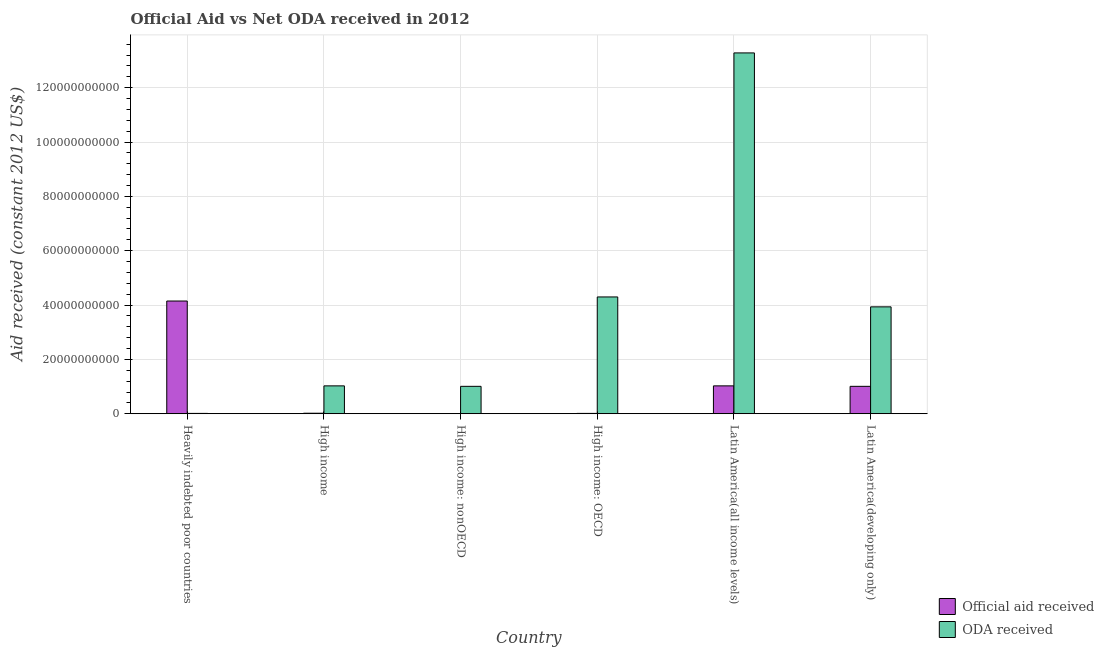How many groups of bars are there?
Offer a very short reply. 6. Are the number of bars per tick equal to the number of legend labels?
Your response must be concise. Yes. How many bars are there on the 3rd tick from the left?
Your answer should be very brief. 2. What is the label of the 4th group of bars from the left?
Your answer should be very brief. High income: OECD. What is the oda received in Heavily indebted poor countries?
Your answer should be very brief. 1.25e+08. Across all countries, what is the maximum official aid received?
Keep it short and to the point. 4.15e+1. Across all countries, what is the minimum official aid received?
Your answer should be compact. 5.78e+07. In which country was the oda received maximum?
Your response must be concise. Latin America(all income levels). In which country was the oda received minimum?
Provide a succinct answer. Heavily indebted poor countries. What is the total oda received in the graph?
Your answer should be very brief. 2.36e+11. What is the difference between the official aid received in High income and that in Latin America(all income levels)?
Provide a succinct answer. -1.01e+1. What is the difference between the oda received in Latin America(developing only) and the official aid received in High income: nonOECD?
Offer a very short reply. 3.93e+1. What is the average official aid received per country?
Provide a succinct answer. 1.04e+1. What is the difference between the official aid received and oda received in Latin America(all income levels)?
Ensure brevity in your answer.  -1.23e+11. In how many countries, is the official aid received greater than 40000000000 US$?
Provide a short and direct response. 1. What is the ratio of the oda received in High income to that in High income: OECD?
Make the answer very short. 0.24. Is the difference between the official aid received in High income and Latin America(all income levels) greater than the difference between the oda received in High income and Latin America(all income levels)?
Provide a short and direct response. Yes. What is the difference between the highest and the second highest oda received?
Ensure brevity in your answer.  8.98e+1. What is the difference between the highest and the lowest official aid received?
Give a very brief answer. 4.14e+1. What does the 1st bar from the left in Latin America(all income levels) represents?
Provide a short and direct response. Official aid received. What does the 2nd bar from the right in Heavily indebted poor countries represents?
Give a very brief answer. Official aid received. Are all the bars in the graph horizontal?
Provide a succinct answer. No. How many countries are there in the graph?
Your answer should be compact. 6. Are the values on the major ticks of Y-axis written in scientific E-notation?
Your answer should be compact. No. Where does the legend appear in the graph?
Offer a very short reply. Bottom right. How are the legend labels stacked?
Your answer should be compact. Vertical. What is the title of the graph?
Keep it short and to the point. Official Aid vs Net ODA received in 2012 . Does "Goods and services" appear as one of the legend labels in the graph?
Make the answer very short. No. What is the label or title of the Y-axis?
Keep it short and to the point. Aid received (constant 2012 US$). What is the Aid received (constant 2012 US$) of Official aid received in Heavily indebted poor countries?
Make the answer very short. 4.15e+1. What is the Aid received (constant 2012 US$) in ODA received in Heavily indebted poor countries?
Provide a short and direct response. 1.25e+08. What is the Aid received (constant 2012 US$) in Official aid received in High income?
Your response must be concise. 1.88e+08. What is the Aid received (constant 2012 US$) in ODA received in High income?
Offer a terse response. 1.03e+1. What is the Aid received (constant 2012 US$) of Official aid received in High income: nonOECD?
Your answer should be compact. 5.78e+07. What is the Aid received (constant 2012 US$) in ODA received in High income: nonOECD?
Your answer should be compact. 1.01e+1. What is the Aid received (constant 2012 US$) of Official aid received in High income: OECD?
Offer a terse response. 1.25e+08. What is the Aid received (constant 2012 US$) in ODA received in High income: OECD?
Keep it short and to the point. 4.30e+1. What is the Aid received (constant 2012 US$) of Official aid received in Latin America(all income levels)?
Offer a very short reply. 1.03e+1. What is the Aid received (constant 2012 US$) of ODA received in Latin America(all income levels)?
Offer a terse response. 1.33e+11. What is the Aid received (constant 2012 US$) in Official aid received in Latin America(developing only)?
Offer a terse response. 1.01e+1. What is the Aid received (constant 2012 US$) in ODA received in Latin America(developing only)?
Keep it short and to the point. 3.93e+1. Across all countries, what is the maximum Aid received (constant 2012 US$) in Official aid received?
Give a very brief answer. 4.15e+1. Across all countries, what is the maximum Aid received (constant 2012 US$) in ODA received?
Offer a very short reply. 1.33e+11. Across all countries, what is the minimum Aid received (constant 2012 US$) of Official aid received?
Give a very brief answer. 5.78e+07. Across all countries, what is the minimum Aid received (constant 2012 US$) in ODA received?
Make the answer very short. 1.25e+08. What is the total Aid received (constant 2012 US$) in Official aid received in the graph?
Give a very brief answer. 6.22e+1. What is the total Aid received (constant 2012 US$) of ODA received in the graph?
Offer a terse response. 2.36e+11. What is the difference between the Aid received (constant 2012 US$) of Official aid received in Heavily indebted poor countries and that in High income?
Give a very brief answer. 4.13e+1. What is the difference between the Aid received (constant 2012 US$) in ODA received in Heavily indebted poor countries and that in High income?
Offer a very short reply. -1.01e+1. What is the difference between the Aid received (constant 2012 US$) in Official aid received in Heavily indebted poor countries and that in High income: nonOECD?
Offer a terse response. 4.14e+1. What is the difference between the Aid received (constant 2012 US$) of ODA received in Heavily indebted poor countries and that in High income: nonOECD?
Keep it short and to the point. -9.96e+09. What is the difference between the Aid received (constant 2012 US$) in Official aid received in Heavily indebted poor countries and that in High income: OECD?
Offer a very short reply. 4.14e+1. What is the difference between the Aid received (constant 2012 US$) of ODA received in Heavily indebted poor countries and that in High income: OECD?
Your answer should be compact. -4.29e+1. What is the difference between the Aid received (constant 2012 US$) of Official aid received in Heavily indebted poor countries and that in Latin America(all income levels)?
Your answer should be very brief. 3.12e+1. What is the difference between the Aid received (constant 2012 US$) of ODA received in Heavily indebted poor countries and that in Latin America(all income levels)?
Your answer should be very brief. -1.33e+11. What is the difference between the Aid received (constant 2012 US$) of Official aid received in Heavily indebted poor countries and that in Latin America(developing only)?
Keep it short and to the point. 3.14e+1. What is the difference between the Aid received (constant 2012 US$) in ODA received in Heavily indebted poor countries and that in Latin America(developing only)?
Ensure brevity in your answer.  -3.92e+1. What is the difference between the Aid received (constant 2012 US$) of Official aid received in High income and that in High income: nonOECD?
Give a very brief answer. 1.30e+08. What is the difference between the Aid received (constant 2012 US$) of ODA received in High income and that in High income: nonOECD?
Give a very brief answer. 1.73e+08. What is the difference between the Aid received (constant 2012 US$) of Official aid received in High income and that in High income: OECD?
Your answer should be compact. 6.28e+07. What is the difference between the Aid received (constant 2012 US$) of ODA received in High income and that in High income: OECD?
Your answer should be very brief. -3.27e+1. What is the difference between the Aid received (constant 2012 US$) of Official aid received in High income and that in Latin America(all income levels)?
Offer a very short reply. -1.01e+1. What is the difference between the Aid received (constant 2012 US$) of ODA received in High income and that in Latin America(all income levels)?
Your answer should be very brief. -1.23e+11. What is the difference between the Aid received (constant 2012 US$) of Official aid received in High income and that in Latin America(developing only)?
Provide a short and direct response. -9.90e+09. What is the difference between the Aid received (constant 2012 US$) of ODA received in High income and that in Latin America(developing only)?
Your answer should be compact. -2.91e+1. What is the difference between the Aid received (constant 2012 US$) in Official aid received in High income: nonOECD and that in High income: OECD?
Offer a terse response. -6.71e+07. What is the difference between the Aid received (constant 2012 US$) of ODA received in High income: nonOECD and that in High income: OECD?
Offer a very short reply. -3.29e+1. What is the difference between the Aid received (constant 2012 US$) of Official aid received in High income: nonOECD and that in Latin America(all income levels)?
Your response must be concise. -1.02e+1. What is the difference between the Aid received (constant 2012 US$) in ODA received in High income: nonOECD and that in Latin America(all income levels)?
Offer a terse response. -1.23e+11. What is the difference between the Aid received (constant 2012 US$) in Official aid received in High income: nonOECD and that in Latin America(developing only)?
Provide a succinct answer. -1.00e+1. What is the difference between the Aid received (constant 2012 US$) in ODA received in High income: nonOECD and that in Latin America(developing only)?
Offer a terse response. -2.93e+1. What is the difference between the Aid received (constant 2012 US$) in Official aid received in High income: OECD and that in Latin America(all income levels)?
Keep it short and to the point. -1.01e+1. What is the difference between the Aid received (constant 2012 US$) in ODA received in High income: OECD and that in Latin America(all income levels)?
Provide a succinct answer. -8.98e+1. What is the difference between the Aid received (constant 2012 US$) of Official aid received in High income: OECD and that in Latin America(developing only)?
Make the answer very short. -9.96e+09. What is the difference between the Aid received (constant 2012 US$) of ODA received in High income: OECD and that in Latin America(developing only)?
Offer a terse response. 3.64e+09. What is the difference between the Aid received (constant 2012 US$) in Official aid received in Latin America(all income levels) and that in Latin America(developing only)?
Offer a terse response. 1.73e+08. What is the difference between the Aid received (constant 2012 US$) in ODA received in Latin America(all income levels) and that in Latin America(developing only)?
Give a very brief answer. 9.35e+1. What is the difference between the Aid received (constant 2012 US$) in Official aid received in Heavily indebted poor countries and the Aid received (constant 2012 US$) in ODA received in High income?
Provide a short and direct response. 3.12e+1. What is the difference between the Aid received (constant 2012 US$) of Official aid received in Heavily indebted poor countries and the Aid received (constant 2012 US$) of ODA received in High income: nonOECD?
Keep it short and to the point. 3.14e+1. What is the difference between the Aid received (constant 2012 US$) in Official aid received in Heavily indebted poor countries and the Aid received (constant 2012 US$) in ODA received in High income: OECD?
Your answer should be compact. -1.50e+09. What is the difference between the Aid received (constant 2012 US$) in Official aid received in Heavily indebted poor countries and the Aid received (constant 2012 US$) in ODA received in Latin America(all income levels)?
Keep it short and to the point. -9.13e+1. What is the difference between the Aid received (constant 2012 US$) of Official aid received in Heavily indebted poor countries and the Aid received (constant 2012 US$) of ODA received in Latin America(developing only)?
Your response must be concise. 2.14e+09. What is the difference between the Aid received (constant 2012 US$) in Official aid received in High income and the Aid received (constant 2012 US$) in ODA received in High income: nonOECD?
Ensure brevity in your answer.  -9.90e+09. What is the difference between the Aid received (constant 2012 US$) in Official aid received in High income and the Aid received (constant 2012 US$) in ODA received in High income: OECD?
Offer a terse response. -4.28e+1. What is the difference between the Aid received (constant 2012 US$) in Official aid received in High income and the Aid received (constant 2012 US$) in ODA received in Latin America(all income levels)?
Offer a very short reply. -1.33e+11. What is the difference between the Aid received (constant 2012 US$) in Official aid received in High income and the Aid received (constant 2012 US$) in ODA received in Latin America(developing only)?
Ensure brevity in your answer.  -3.91e+1. What is the difference between the Aid received (constant 2012 US$) of Official aid received in High income: nonOECD and the Aid received (constant 2012 US$) of ODA received in High income: OECD?
Keep it short and to the point. -4.29e+1. What is the difference between the Aid received (constant 2012 US$) of Official aid received in High income: nonOECD and the Aid received (constant 2012 US$) of ODA received in Latin America(all income levels)?
Make the answer very short. -1.33e+11. What is the difference between the Aid received (constant 2012 US$) of Official aid received in High income: nonOECD and the Aid received (constant 2012 US$) of ODA received in Latin America(developing only)?
Provide a short and direct response. -3.93e+1. What is the difference between the Aid received (constant 2012 US$) of Official aid received in High income: OECD and the Aid received (constant 2012 US$) of ODA received in Latin America(all income levels)?
Keep it short and to the point. -1.33e+11. What is the difference between the Aid received (constant 2012 US$) of Official aid received in High income: OECD and the Aid received (constant 2012 US$) of ODA received in Latin America(developing only)?
Provide a succinct answer. -3.92e+1. What is the difference between the Aid received (constant 2012 US$) in Official aid received in Latin America(all income levels) and the Aid received (constant 2012 US$) in ODA received in Latin America(developing only)?
Offer a terse response. -2.91e+1. What is the average Aid received (constant 2012 US$) in Official aid received per country?
Give a very brief answer. 1.04e+1. What is the average Aid received (constant 2012 US$) in ODA received per country?
Ensure brevity in your answer.  3.93e+1. What is the difference between the Aid received (constant 2012 US$) of Official aid received and Aid received (constant 2012 US$) of ODA received in Heavily indebted poor countries?
Keep it short and to the point. 4.14e+1. What is the difference between the Aid received (constant 2012 US$) of Official aid received and Aid received (constant 2012 US$) of ODA received in High income?
Make the answer very short. -1.01e+1. What is the difference between the Aid received (constant 2012 US$) in Official aid received and Aid received (constant 2012 US$) in ODA received in High income: nonOECD?
Your response must be concise. -1.00e+1. What is the difference between the Aid received (constant 2012 US$) in Official aid received and Aid received (constant 2012 US$) in ODA received in High income: OECD?
Your response must be concise. -4.29e+1. What is the difference between the Aid received (constant 2012 US$) of Official aid received and Aid received (constant 2012 US$) of ODA received in Latin America(all income levels)?
Ensure brevity in your answer.  -1.23e+11. What is the difference between the Aid received (constant 2012 US$) of Official aid received and Aid received (constant 2012 US$) of ODA received in Latin America(developing only)?
Provide a succinct answer. -2.93e+1. What is the ratio of the Aid received (constant 2012 US$) of Official aid received in Heavily indebted poor countries to that in High income?
Offer a terse response. 221.03. What is the ratio of the Aid received (constant 2012 US$) in ODA received in Heavily indebted poor countries to that in High income?
Your answer should be very brief. 0.01. What is the ratio of the Aid received (constant 2012 US$) in Official aid received in Heavily indebted poor countries to that in High income: nonOECD?
Give a very brief answer. 717.88. What is the ratio of the Aid received (constant 2012 US$) in ODA received in Heavily indebted poor countries to that in High income: nonOECD?
Keep it short and to the point. 0.01. What is the ratio of the Aid received (constant 2012 US$) in Official aid received in Heavily indebted poor countries to that in High income: OECD?
Ensure brevity in your answer.  332.26. What is the ratio of the Aid received (constant 2012 US$) of ODA received in Heavily indebted poor countries to that in High income: OECD?
Keep it short and to the point. 0. What is the ratio of the Aid received (constant 2012 US$) in Official aid received in Heavily indebted poor countries to that in Latin America(all income levels)?
Your answer should be compact. 4.04. What is the ratio of the Aid received (constant 2012 US$) of ODA received in Heavily indebted poor countries to that in Latin America(all income levels)?
Make the answer very short. 0. What is the ratio of the Aid received (constant 2012 US$) of Official aid received in Heavily indebted poor countries to that in Latin America(developing only)?
Keep it short and to the point. 4.11. What is the ratio of the Aid received (constant 2012 US$) of ODA received in Heavily indebted poor countries to that in Latin America(developing only)?
Provide a short and direct response. 0. What is the ratio of the Aid received (constant 2012 US$) in Official aid received in High income to that in High income: nonOECD?
Offer a terse response. 3.25. What is the ratio of the Aid received (constant 2012 US$) of ODA received in High income to that in High income: nonOECD?
Offer a terse response. 1.02. What is the ratio of the Aid received (constant 2012 US$) of Official aid received in High income to that in High income: OECD?
Offer a terse response. 1.5. What is the ratio of the Aid received (constant 2012 US$) in ODA received in High income to that in High income: OECD?
Give a very brief answer. 0.24. What is the ratio of the Aid received (constant 2012 US$) of Official aid received in High income to that in Latin America(all income levels)?
Offer a terse response. 0.02. What is the ratio of the Aid received (constant 2012 US$) in ODA received in High income to that in Latin America(all income levels)?
Your response must be concise. 0.08. What is the ratio of the Aid received (constant 2012 US$) in Official aid received in High income to that in Latin America(developing only)?
Ensure brevity in your answer.  0.02. What is the ratio of the Aid received (constant 2012 US$) of ODA received in High income to that in Latin America(developing only)?
Offer a terse response. 0.26. What is the ratio of the Aid received (constant 2012 US$) in Official aid received in High income: nonOECD to that in High income: OECD?
Your response must be concise. 0.46. What is the ratio of the Aid received (constant 2012 US$) of ODA received in High income: nonOECD to that in High income: OECD?
Keep it short and to the point. 0.23. What is the ratio of the Aid received (constant 2012 US$) in Official aid received in High income: nonOECD to that in Latin America(all income levels)?
Provide a succinct answer. 0.01. What is the ratio of the Aid received (constant 2012 US$) in ODA received in High income: nonOECD to that in Latin America(all income levels)?
Your answer should be compact. 0.08. What is the ratio of the Aid received (constant 2012 US$) of Official aid received in High income: nonOECD to that in Latin America(developing only)?
Provide a succinct answer. 0.01. What is the ratio of the Aid received (constant 2012 US$) of ODA received in High income: nonOECD to that in Latin America(developing only)?
Your response must be concise. 0.26. What is the ratio of the Aid received (constant 2012 US$) of Official aid received in High income: OECD to that in Latin America(all income levels)?
Give a very brief answer. 0.01. What is the ratio of the Aid received (constant 2012 US$) in ODA received in High income: OECD to that in Latin America(all income levels)?
Provide a succinct answer. 0.32. What is the ratio of the Aid received (constant 2012 US$) in Official aid received in High income: OECD to that in Latin America(developing only)?
Your answer should be very brief. 0.01. What is the ratio of the Aid received (constant 2012 US$) in ODA received in High income: OECD to that in Latin America(developing only)?
Your answer should be very brief. 1.09. What is the ratio of the Aid received (constant 2012 US$) of Official aid received in Latin America(all income levels) to that in Latin America(developing only)?
Your answer should be very brief. 1.02. What is the ratio of the Aid received (constant 2012 US$) in ODA received in Latin America(all income levels) to that in Latin America(developing only)?
Keep it short and to the point. 3.38. What is the difference between the highest and the second highest Aid received (constant 2012 US$) of Official aid received?
Provide a short and direct response. 3.12e+1. What is the difference between the highest and the second highest Aid received (constant 2012 US$) of ODA received?
Your answer should be very brief. 8.98e+1. What is the difference between the highest and the lowest Aid received (constant 2012 US$) in Official aid received?
Provide a succinct answer. 4.14e+1. What is the difference between the highest and the lowest Aid received (constant 2012 US$) of ODA received?
Give a very brief answer. 1.33e+11. 